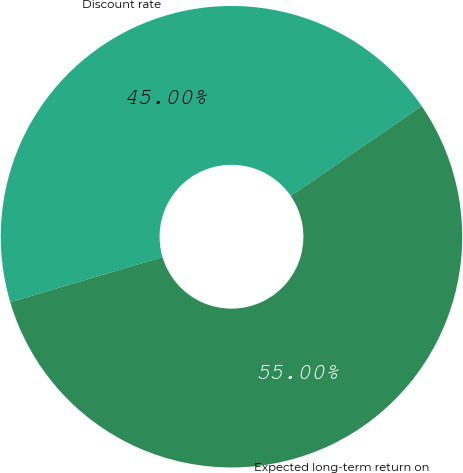Convert chart to OTSL. <chart><loc_0><loc_0><loc_500><loc_500><pie_chart><fcel>Discount rate<fcel>Expected long-term return on<nl><fcel>45.0%<fcel>55.0%<nl></chart> 